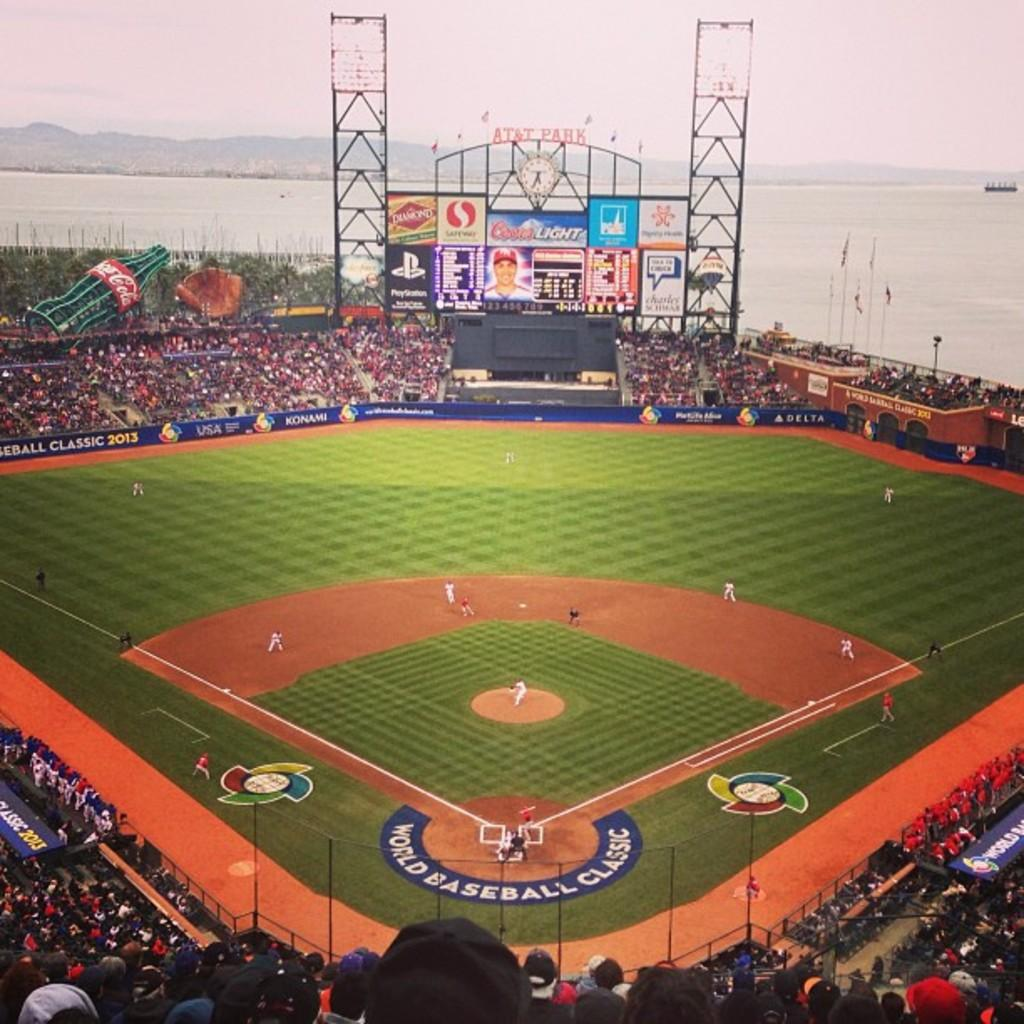<image>
Summarize the visual content of the image. Baseball stadium with a horseshoe logo World Baseball club. 